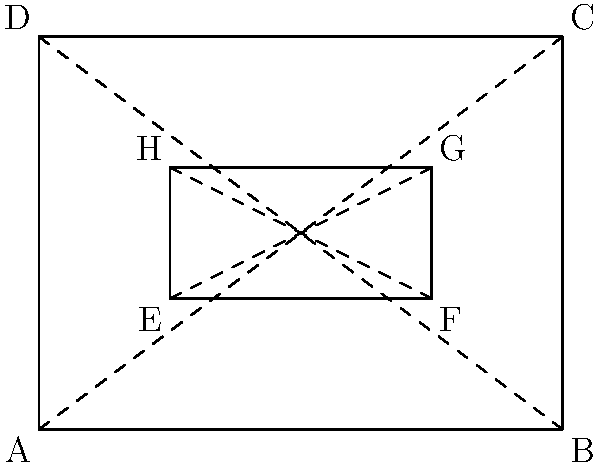In the cross-section of a 3D-modeled weapon prop, two rectangles ABCD and EFGH are shown. If $\overline{AB} = 4$ units, $\overline{AD} = 3$ units, $\overline{EF} = 2$ units, and $\overline{EH} = 1$ unit, prove that triangles AEB and DGC are congruent. To prove that triangles AEB and DGC are congruent, we'll use the Side-Angle-Side (SAS) congruence criterion. Let's follow these steps:

1. First, we need to show that $\overline{AE} \cong \overline{DG}$:
   - $\overline{AE} = \overline{DG} = 1$ unit (given that $\overline{EH} = 1$ unit and EFGH is a rectangle)

2. Next, we'll prove that $\angle EAB \cong \angle GDC$:
   - $\angle EAB$ and $\angle GDC$ are both right angles (as they're angles in rectangles)
   - Right angles are always congruent

3. Finally, we'll show that $\overline{AB} \cong \overline{DC}$:
   - $\overline{AB} = \overline{DC} = 4$ units (given)

4. Apply the SAS congruence criterion:
   - We have shown that $\overline{AE} \cong \overline{DG}$ (side)
   - $\angle EAB \cong \angle GDC$ (angle)
   - $\overline{AB} \cong \overline{DC}$ (side)

Therefore, by the SAS congruence criterion, triangles AEB and DGC are congruent.
Answer: SAS congruence 